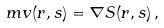<formula> <loc_0><loc_0><loc_500><loc_500>m { v } ( { r } , s ) = \nabla S ( { r } , s ) \, ,</formula> 